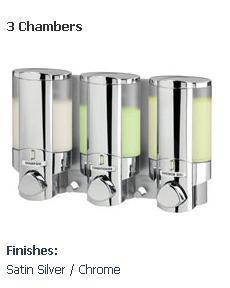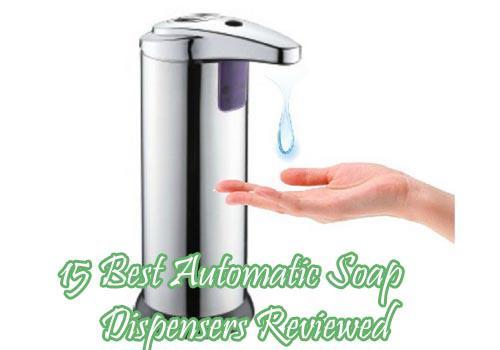The first image is the image on the left, the second image is the image on the right. Evaluate the accuracy of this statement regarding the images: "There are exactly four dispensers, and at least of them are chrome.". Is it true? Answer yes or no. Yes. The first image is the image on the left, the second image is the image on the right. For the images shown, is this caption "A person is getting soap from a dispenser in the image on the right." true? Answer yes or no. Yes. 